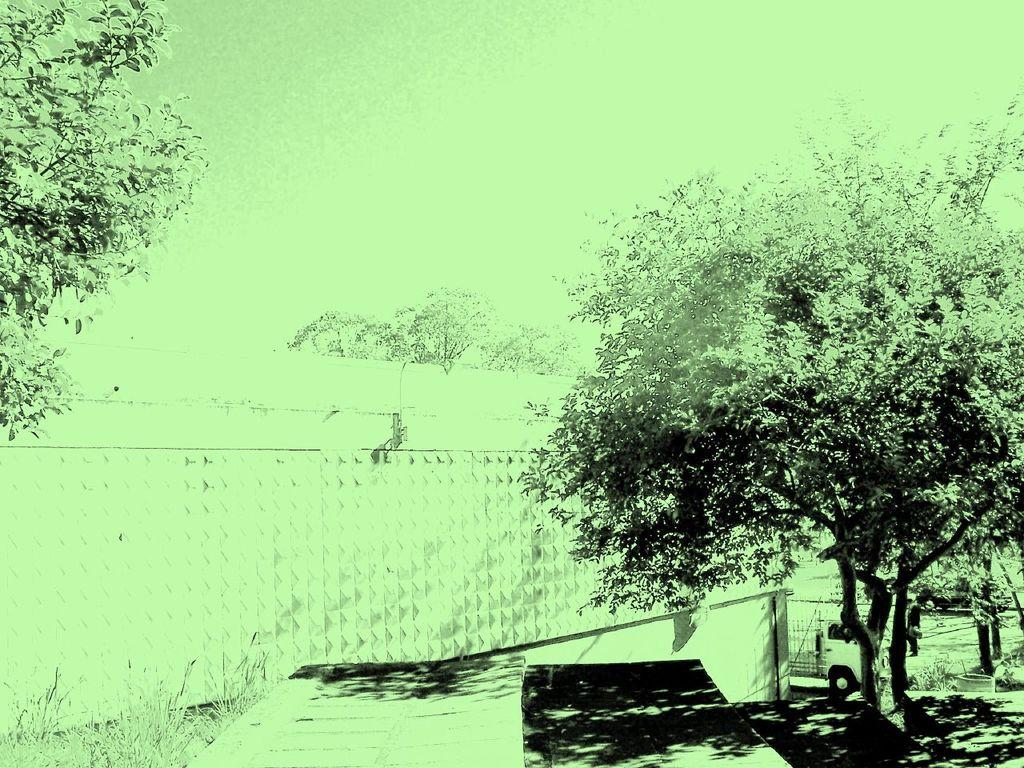What type of natural elements can be seen in the image? There are trees and plants in the image. What type of man-made structure is present in the image? There is a wall in the image. What mode of transportation is visible in the image? There is a vehicle in the image. Is there a person present in the image? Yes, there is a person in the image. What other objects can be seen in the image? There are other objects in the image, but their specific details are not mentioned in the facts. What is visible at the top of the image? The sky is visible at the top of the image. What type of baseball equipment can be seen in the image? There is no baseball equipment present in the image. What is the cause of death for the person in the image? There is no indication of death or any related information in the image. 